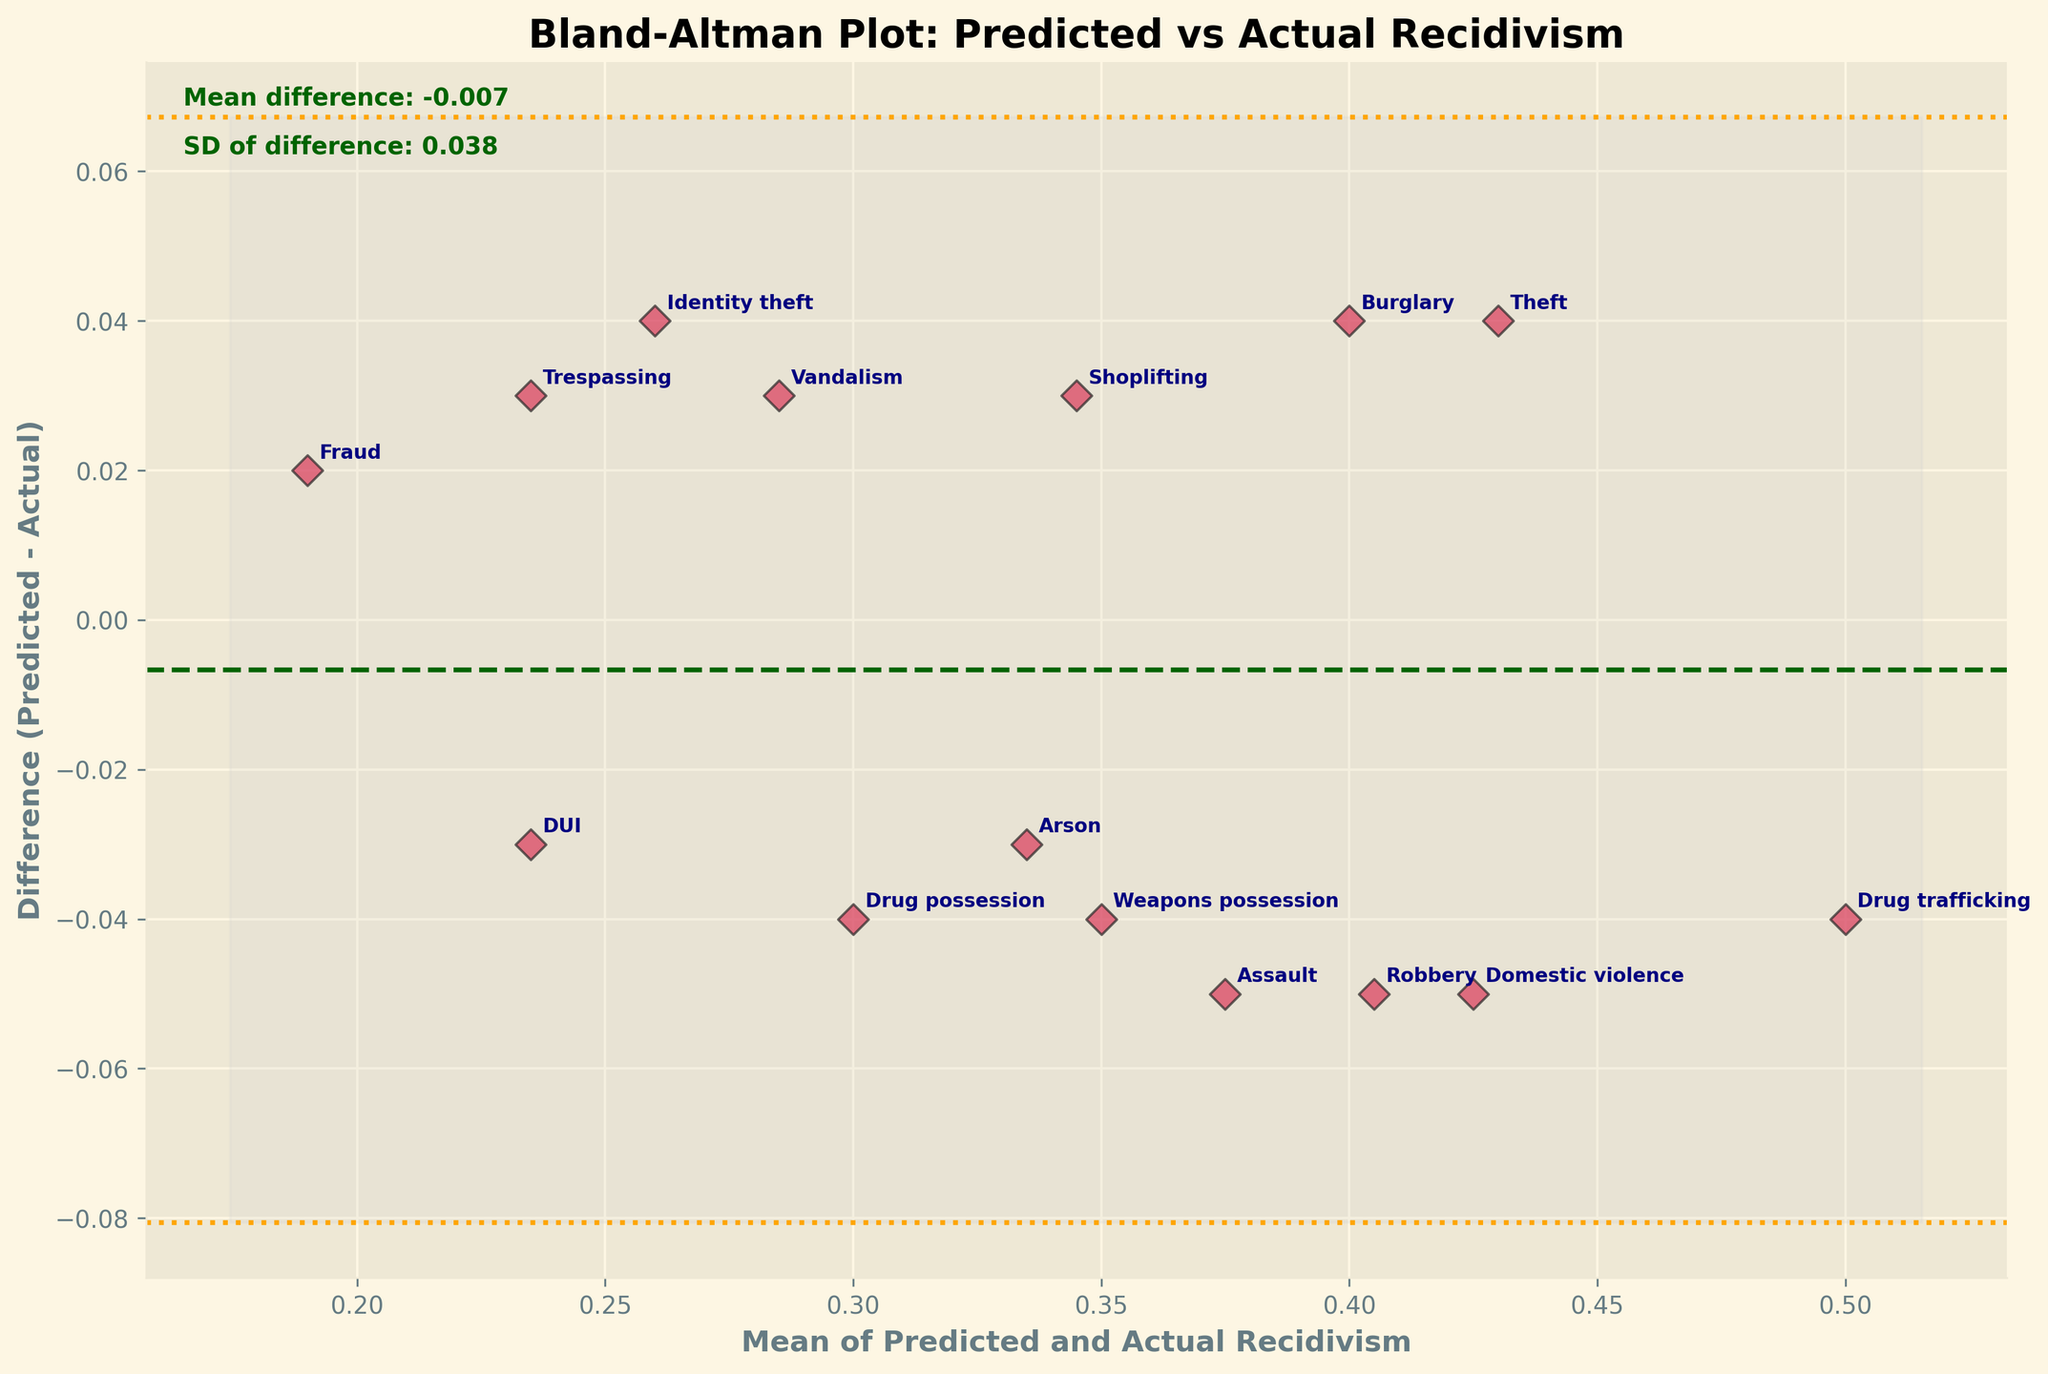What is the title of the plot? The title of the plot is typically found at the top of the figure. In this case, the title is 'Bland-Altman Plot: Predicted vs Actual Recidivism'.
Answer: Bland-Altman Plot: Predicted vs Actual Recidivism Which axis represents the mean of predicted and actual recidivism rates? To determine the axes, look at the axis labels. The x-axis is labeled 'Mean of Predicted and Actual Recidivism', hence it represents the mean of the recidivism rates.
Answer: x-axis How many data points are plotted in the figure? Each data point represents an offense type, which can be counted. The number of offense types provided or labels on the plot is 15.
Answer: 15 What is the color used for the data points in the plot? The scatter points are described as being colored 'crimson' and having a black edge in the code. This meets the description seen visually.
Answer: Crimson with black edges What is the mean difference between predicted and actual recidivism rates? The mean difference (md) is visually mentioned on the plot, which is calculated and displayed as around 0.013.
Answer: 0.013 Which offense type has the highest positive difference between predicted and actual recidivism rates? The difference for each offense type is given by (Predicted - Actual). By inspecting the plot or labeled points, Drug trafficking stands out as the offense with the highest positive difference.
Answer: Drug trafficking What are the lines above and below the mean difference line called? These lines represent the limits of agreement, calculated as the mean difference ± 1.96 times the standard deviation of the differences. There are two lines, one above and one below.
Answer: Limits of agreement What is the value of the upper limit of agreement? To find this value, add 1.96 times the standard deviation to the mean difference. It is also typically marked on the plot. In this case, it's 0.013 + (1.96 * 0.073) = approx 0.156.
Answer: 0.156 Which offense type has the closest predicted and actual recidivism rates? The offense type with the smallest difference (Predicted - Actual) would have the closest rates. From the plot, Fraud seems to have the smallest difference.
Answer: Fraud Are there any offense types where the predicted recidivism rate is lower than the actual recidivism rate? Give one example if so. By checking if predicted < actual for any points, these are below the zero line on the plot. An example of such an offense type is Robbery.
Answer: Robbery 